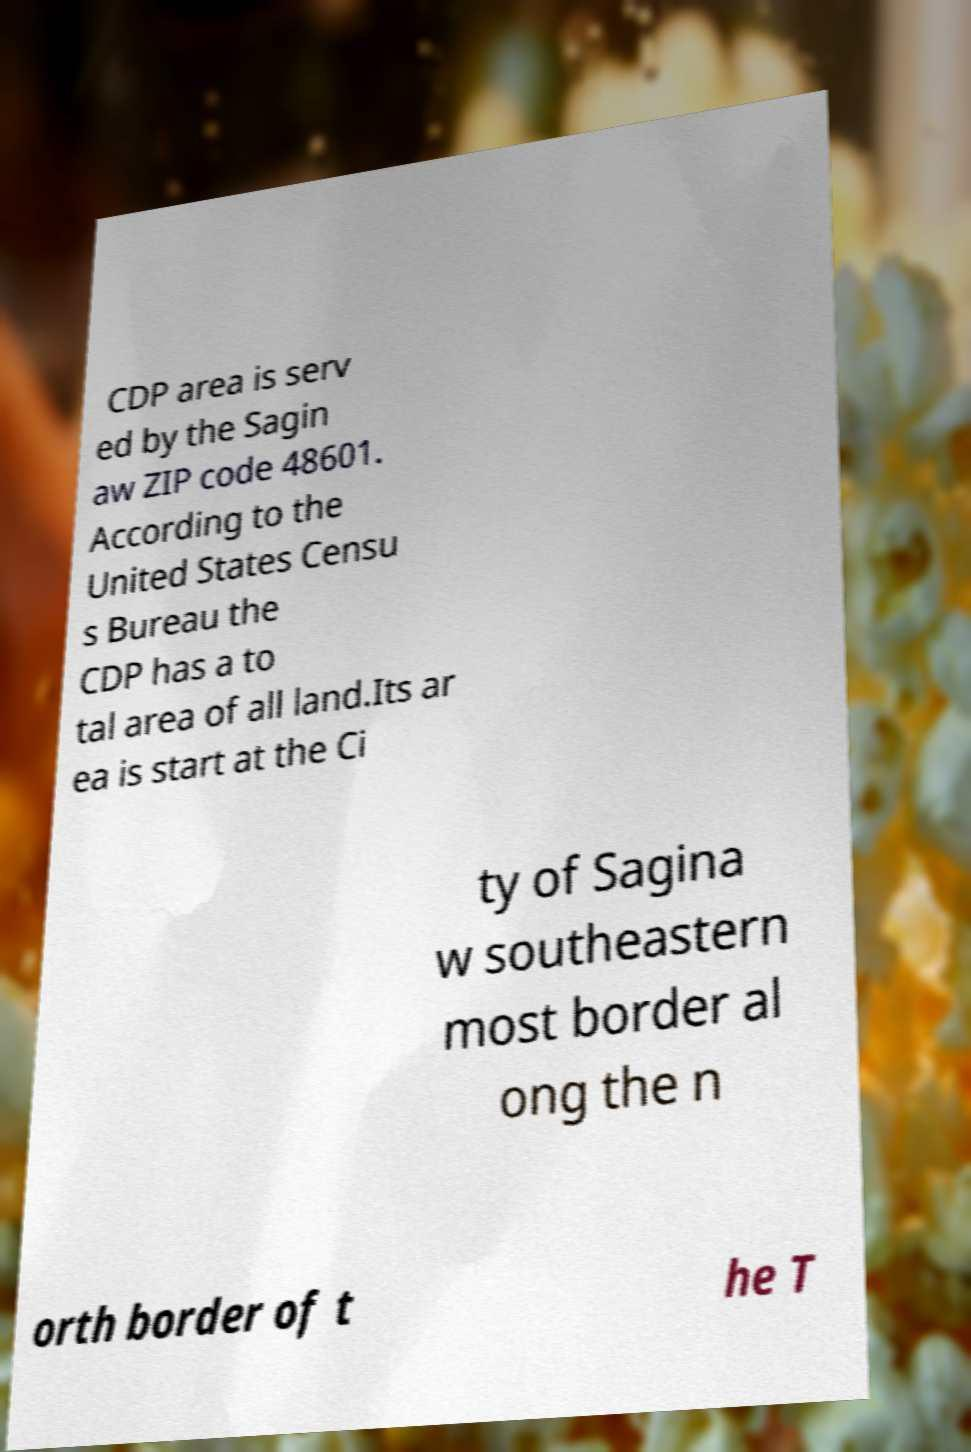Can you read and provide the text displayed in the image?This photo seems to have some interesting text. Can you extract and type it out for me? CDP area is serv ed by the Sagin aw ZIP code 48601. According to the United States Censu s Bureau the CDP has a to tal area of all land.Its ar ea is start at the Ci ty of Sagina w southeastern most border al ong the n orth border of t he T 